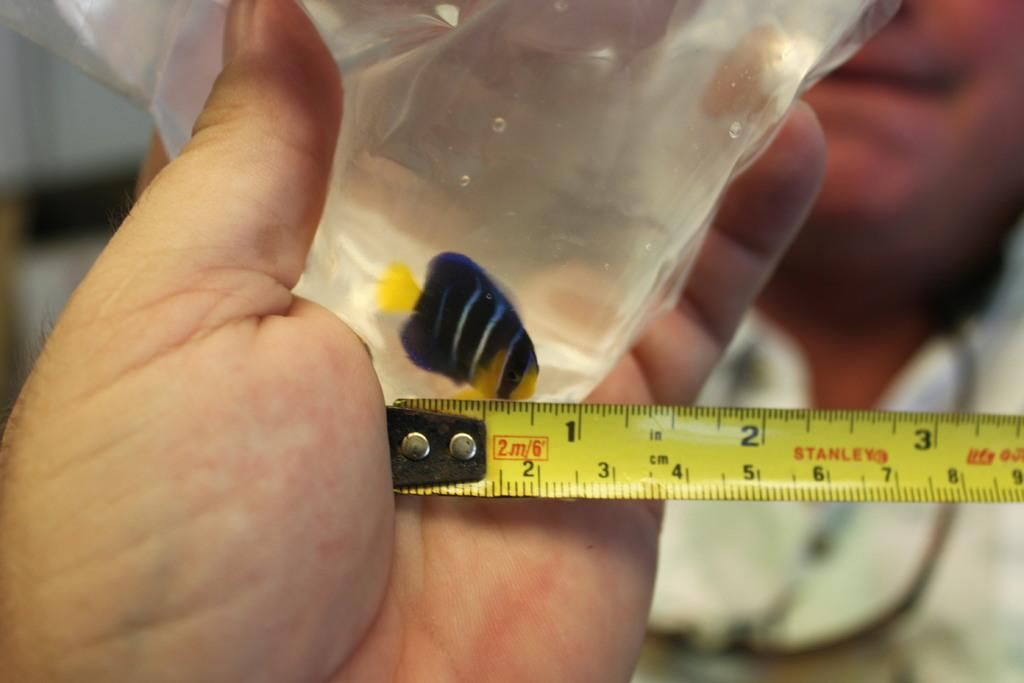<image>
Offer a succinct explanation of the picture presented. A person holding a yellow tape measure that measures at least 9 centimeters. 